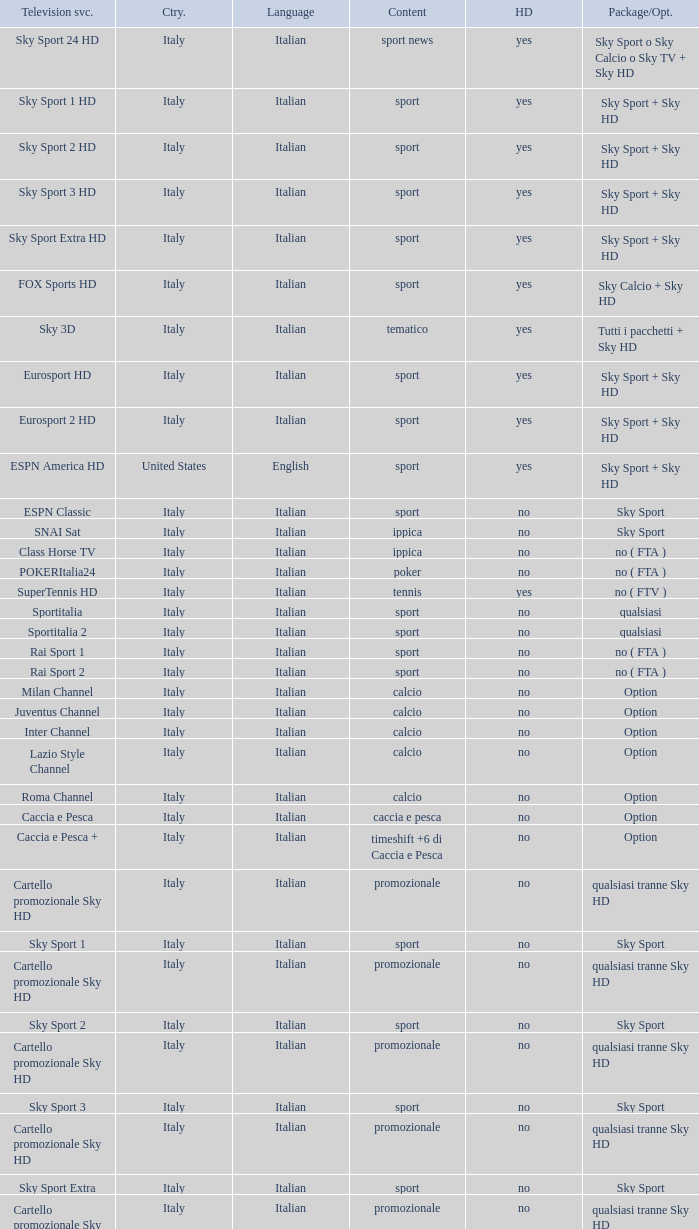Give me the full table as a dictionary. {'header': ['Television svc.', 'Ctry.', 'Language', 'Content', 'HD', 'Package/Opt.'], 'rows': [['Sky Sport 24 HD', 'Italy', 'Italian', 'sport news', 'yes', 'Sky Sport o Sky Calcio o Sky TV + Sky HD'], ['Sky Sport 1 HD', 'Italy', 'Italian', 'sport', 'yes', 'Sky Sport + Sky HD'], ['Sky Sport 2 HD', 'Italy', 'Italian', 'sport', 'yes', 'Sky Sport + Sky HD'], ['Sky Sport 3 HD', 'Italy', 'Italian', 'sport', 'yes', 'Sky Sport + Sky HD'], ['Sky Sport Extra HD', 'Italy', 'Italian', 'sport', 'yes', 'Sky Sport + Sky HD'], ['FOX Sports HD', 'Italy', 'Italian', 'sport', 'yes', 'Sky Calcio + Sky HD'], ['Sky 3D', 'Italy', 'Italian', 'tematico', 'yes', 'Tutti i pacchetti + Sky HD'], ['Eurosport HD', 'Italy', 'Italian', 'sport', 'yes', 'Sky Sport + Sky HD'], ['Eurosport 2 HD', 'Italy', 'Italian', 'sport', 'yes', 'Sky Sport + Sky HD'], ['ESPN America HD', 'United States', 'English', 'sport', 'yes', 'Sky Sport + Sky HD'], ['ESPN Classic', 'Italy', 'Italian', 'sport', 'no', 'Sky Sport'], ['SNAI Sat', 'Italy', 'Italian', 'ippica', 'no', 'Sky Sport'], ['Class Horse TV', 'Italy', 'Italian', 'ippica', 'no', 'no ( FTA )'], ['POKERItalia24', 'Italy', 'Italian', 'poker', 'no', 'no ( FTA )'], ['SuperTennis HD', 'Italy', 'Italian', 'tennis', 'yes', 'no ( FTV )'], ['Sportitalia', 'Italy', 'Italian', 'sport', 'no', 'qualsiasi'], ['Sportitalia 2', 'Italy', 'Italian', 'sport', 'no', 'qualsiasi'], ['Rai Sport 1', 'Italy', 'Italian', 'sport', 'no', 'no ( FTA )'], ['Rai Sport 2', 'Italy', 'Italian', 'sport', 'no', 'no ( FTA )'], ['Milan Channel', 'Italy', 'Italian', 'calcio', 'no', 'Option'], ['Juventus Channel', 'Italy', 'Italian', 'calcio', 'no', 'Option'], ['Inter Channel', 'Italy', 'Italian', 'calcio', 'no', 'Option'], ['Lazio Style Channel', 'Italy', 'Italian', 'calcio', 'no', 'Option'], ['Roma Channel', 'Italy', 'Italian', 'calcio', 'no', 'Option'], ['Caccia e Pesca', 'Italy', 'Italian', 'caccia e pesca', 'no', 'Option'], ['Caccia e Pesca +', 'Italy', 'Italian', 'timeshift +6 di Caccia e Pesca', 'no', 'Option'], ['Cartello promozionale Sky HD', 'Italy', 'Italian', 'promozionale', 'no', 'qualsiasi tranne Sky HD'], ['Sky Sport 1', 'Italy', 'Italian', 'sport', 'no', 'Sky Sport'], ['Cartello promozionale Sky HD', 'Italy', 'Italian', 'promozionale', 'no', 'qualsiasi tranne Sky HD'], ['Sky Sport 2', 'Italy', 'Italian', 'sport', 'no', 'Sky Sport'], ['Cartello promozionale Sky HD', 'Italy', 'Italian', 'promozionale', 'no', 'qualsiasi tranne Sky HD'], ['Sky Sport 3', 'Italy', 'Italian', 'sport', 'no', 'Sky Sport'], ['Cartello promozionale Sky HD', 'Italy', 'Italian', 'promozionale', 'no', 'qualsiasi tranne Sky HD'], ['Sky Sport Extra', 'Italy', 'Italian', 'sport', 'no', 'Sky Sport'], ['Cartello promozionale Sky HD', 'Italy', 'Italian', 'promozionale', 'no', 'qualsiasi tranne Sky HD'], ['Sky Supercalcio', 'Italy', 'Italian', 'calcio', 'no', 'Sky Calcio'], ['Cartello promozionale Sky HD', 'Italy', 'Italian', 'promozionale', 'no', 'qualsiasi tranne Sky HD'], ['Eurosport', 'Italy', 'Italian', 'sport', 'no', 'Sky Sport'], ['Eurosport 2', 'Italy', 'Italian', 'sport', 'no', 'Sky Sport'], ['ESPN America', 'Italy', 'Italian', 'sport', 'no', 'Sky Sport']]} What is Country, when Television Service is Eurosport 2? Italy. 